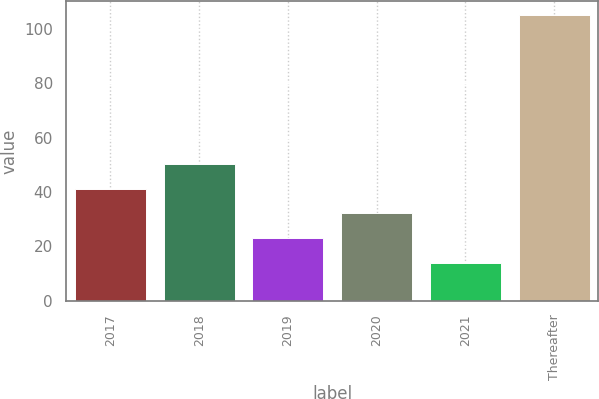Convert chart to OTSL. <chart><loc_0><loc_0><loc_500><loc_500><bar_chart><fcel>2017<fcel>2018<fcel>2019<fcel>2020<fcel>2021<fcel>Thereafter<nl><fcel>41.3<fcel>50.4<fcel>23.1<fcel>32.2<fcel>14<fcel>105<nl></chart> 